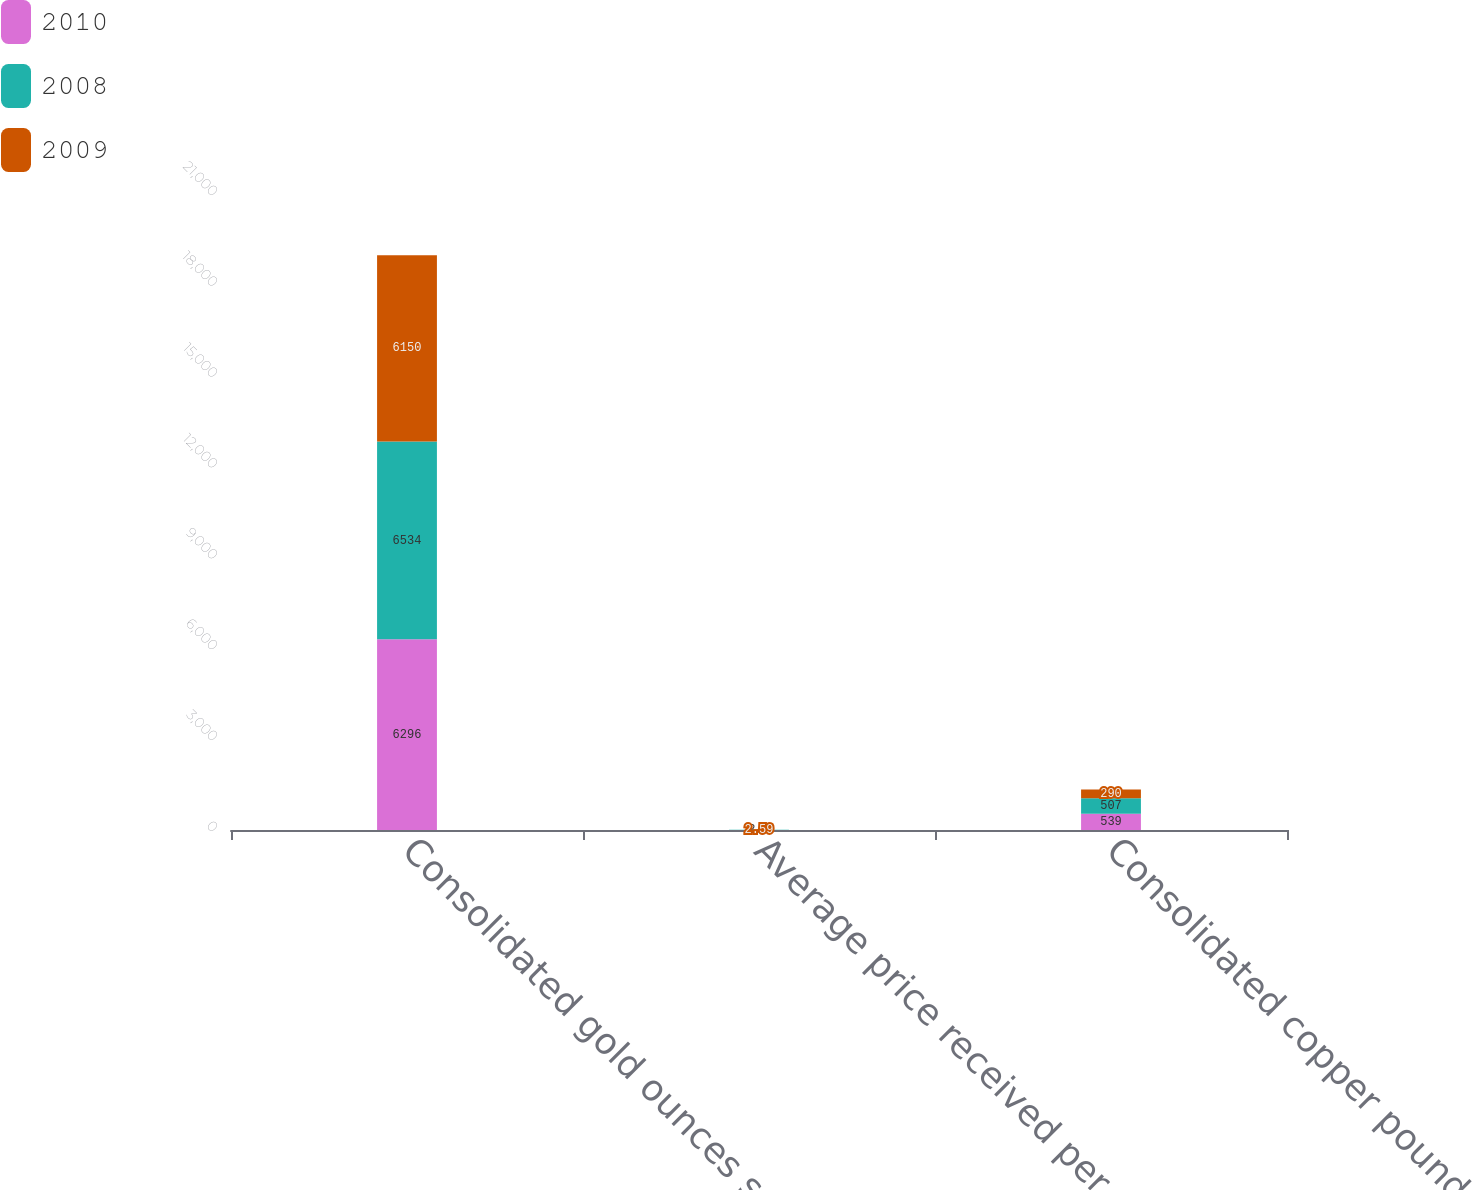Convert chart. <chart><loc_0><loc_0><loc_500><loc_500><stacked_bar_chart><ecel><fcel>Consolidated gold ounces sold<fcel>Average price received per<fcel>Consolidated copper pounds<nl><fcel>2010<fcel>6296<fcel>3.43<fcel>539<nl><fcel>2008<fcel>6534<fcel>2.6<fcel>507<nl><fcel>2009<fcel>6150<fcel>2.59<fcel>290<nl></chart> 